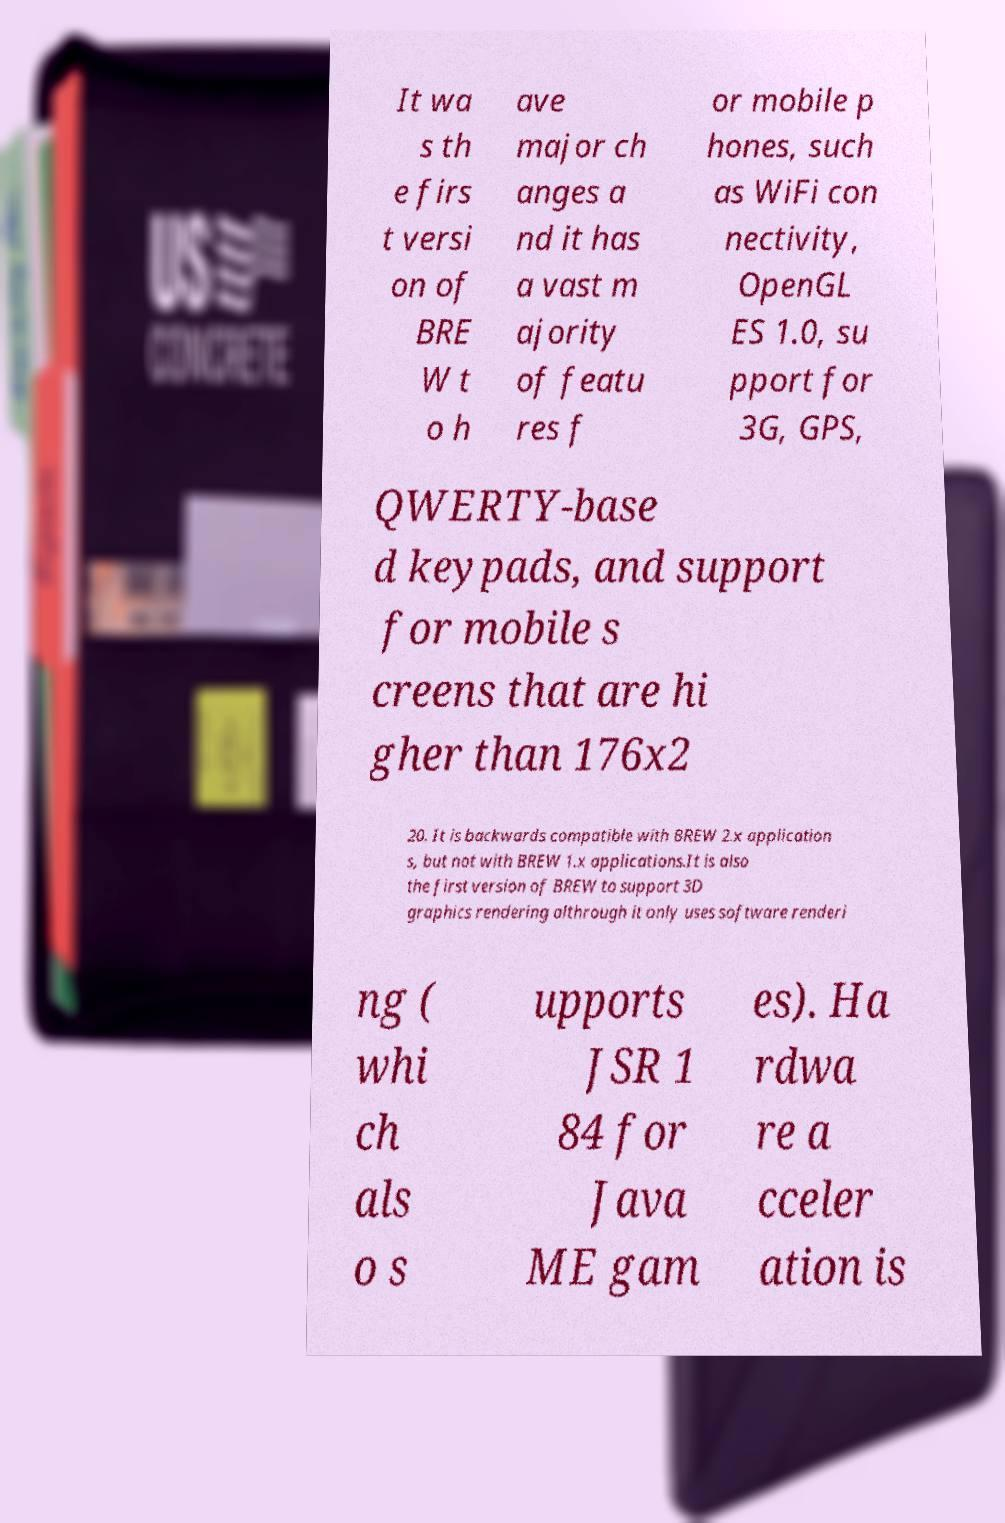I need the written content from this picture converted into text. Can you do that? It wa s th e firs t versi on of BRE W t o h ave major ch anges a nd it has a vast m ajority of featu res f or mobile p hones, such as WiFi con nectivity, OpenGL ES 1.0, su pport for 3G, GPS, QWERTY-base d keypads, and support for mobile s creens that are hi gher than 176x2 20. It is backwards compatible with BREW 2.x application s, but not with BREW 1.x applications.It is also the first version of BREW to support 3D graphics rendering althrough it only uses software renderi ng ( whi ch als o s upports JSR 1 84 for Java ME gam es). Ha rdwa re a cceler ation is 